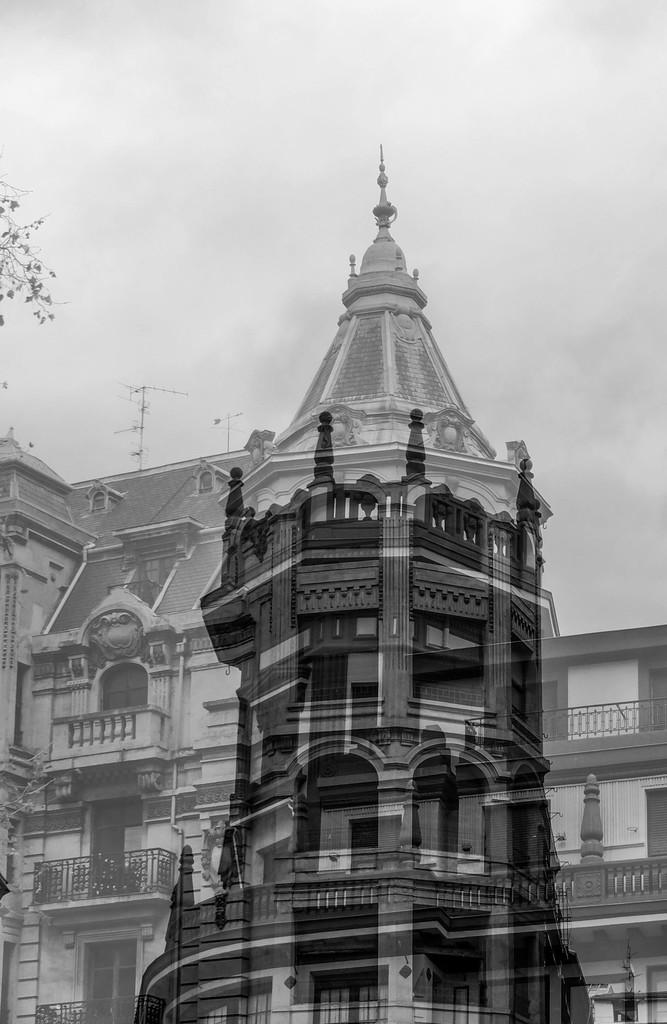What is the color scheme of the image? The image is black and white in color. What type of structure can be seen in the image? There is a building in the image. What type of vegetation is visible in the image? There are leaves visible in the image. What is visible in the background of the image? The sky is visible in the background of the image. What type of behavior do the girls exhibit in the image? There are no girls present in the image, so their behavior cannot be observed. What type of soda is being served in the image? There is no soda present in the image. 